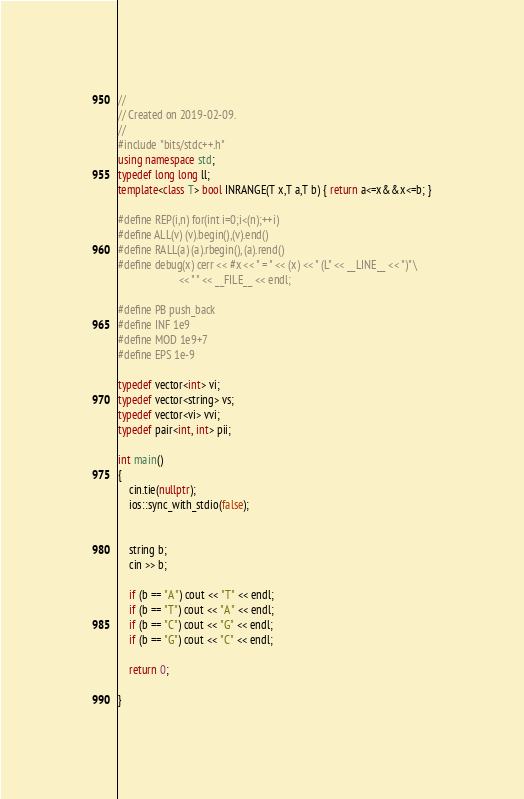Convert code to text. <code><loc_0><loc_0><loc_500><loc_500><_C++_>//
// Created on 2019-02-09.
//
#include "bits/stdc++.h"
using namespace std;
typedef long long ll;
template<class T> bool INRANGE(T x,T a,T b) { return a<=x&&x<=b; }

#define REP(i,n) for(int i=0;i<(n);++i)
#define ALL(v) (v).begin(),(v).end()
#define RALL(a) (a).rbegin(), (a).rend()
#define debug(x) cerr << #x << " = " << (x) << " (L" << __LINE__ << ")" \
                      << " " << __FILE__ << endl;

#define PB push_back
#define INF 1e9
#define MOD 1e9+7
#define EPS 1e-9

typedef vector<int> vi;
typedef vector<string> vs;
typedef vector<vi> vvi;
typedef pair<int, int> pii;

int main()
{
    cin.tie(nullptr);
    ios::sync_with_stdio(false);


    string b;
    cin >> b;

    if (b == "A") cout << "T" << endl;
    if (b == "T") cout << "A" << endl;
    if (b == "C") cout << "G" << endl;
    if (b == "G") cout << "C" << endl;

    return 0;

}</code> 